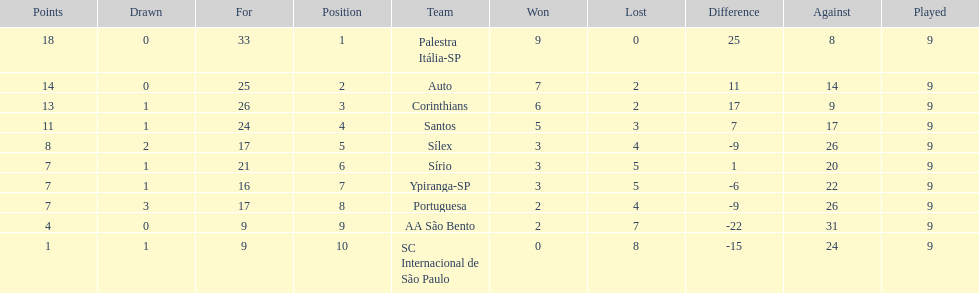Which team was the only team that was undefeated? Palestra Itália-SP. 